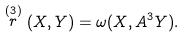Convert formula to latex. <formula><loc_0><loc_0><loc_500><loc_500>\stackrel { ( 3 ) } { r } ( X , Y ) = \omega ( X , A ^ { 3 } Y ) .</formula> 